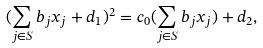<formula> <loc_0><loc_0><loc_500><loc_500>( \sum _ { j \in S } b _ { j } x _ { j } + d _ { 1 } ) ^ { 2 } = c _ { 0 } ( \sum _ { j \in S } b _ { j } x _ { j } ) + d _ { 2 } ,</formula> 